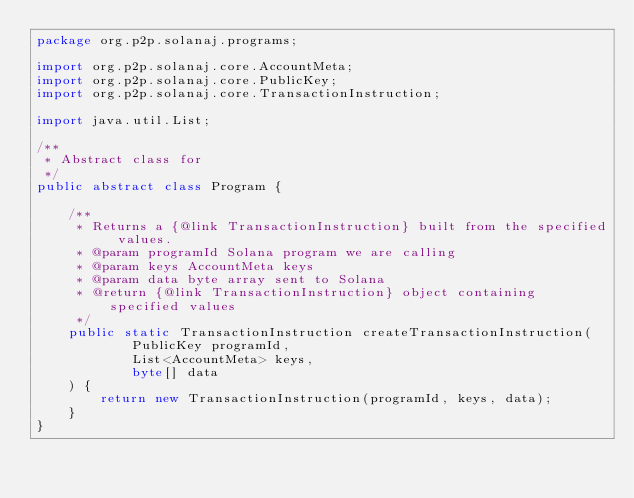Convert code to text. <code><loc_0><loc_0><loc_500><loc_500><_Java_>package org.p2p.solanaj.programs;

import org.p2p.solanaj.core.AccountMeta;
import org.p2p.solanaj.core.PublicKey;
import org.p2p.solanaj.core.TransactionInstruction;

import java.util.List;

/**
 * Abstract class for
 */
public abstract class Program {

    /**
     * Returns a {@link TransactionInstruction} built from the specified values.
     * @param programId Solana program we are calling
     * @param keys AccountMeta keys
     * @param data byte array sent to Solana
     * @return {@link TransactionInstruction} object containing specified values
     */
    public static TransactionInstruction createTransactionInstruction(
            PublicKey programId,
            List<AccountMeta> keys,
            byte[] data
    ) {
        return new TransactionInstruction(programId, keys, data);
    }
}
</code> 